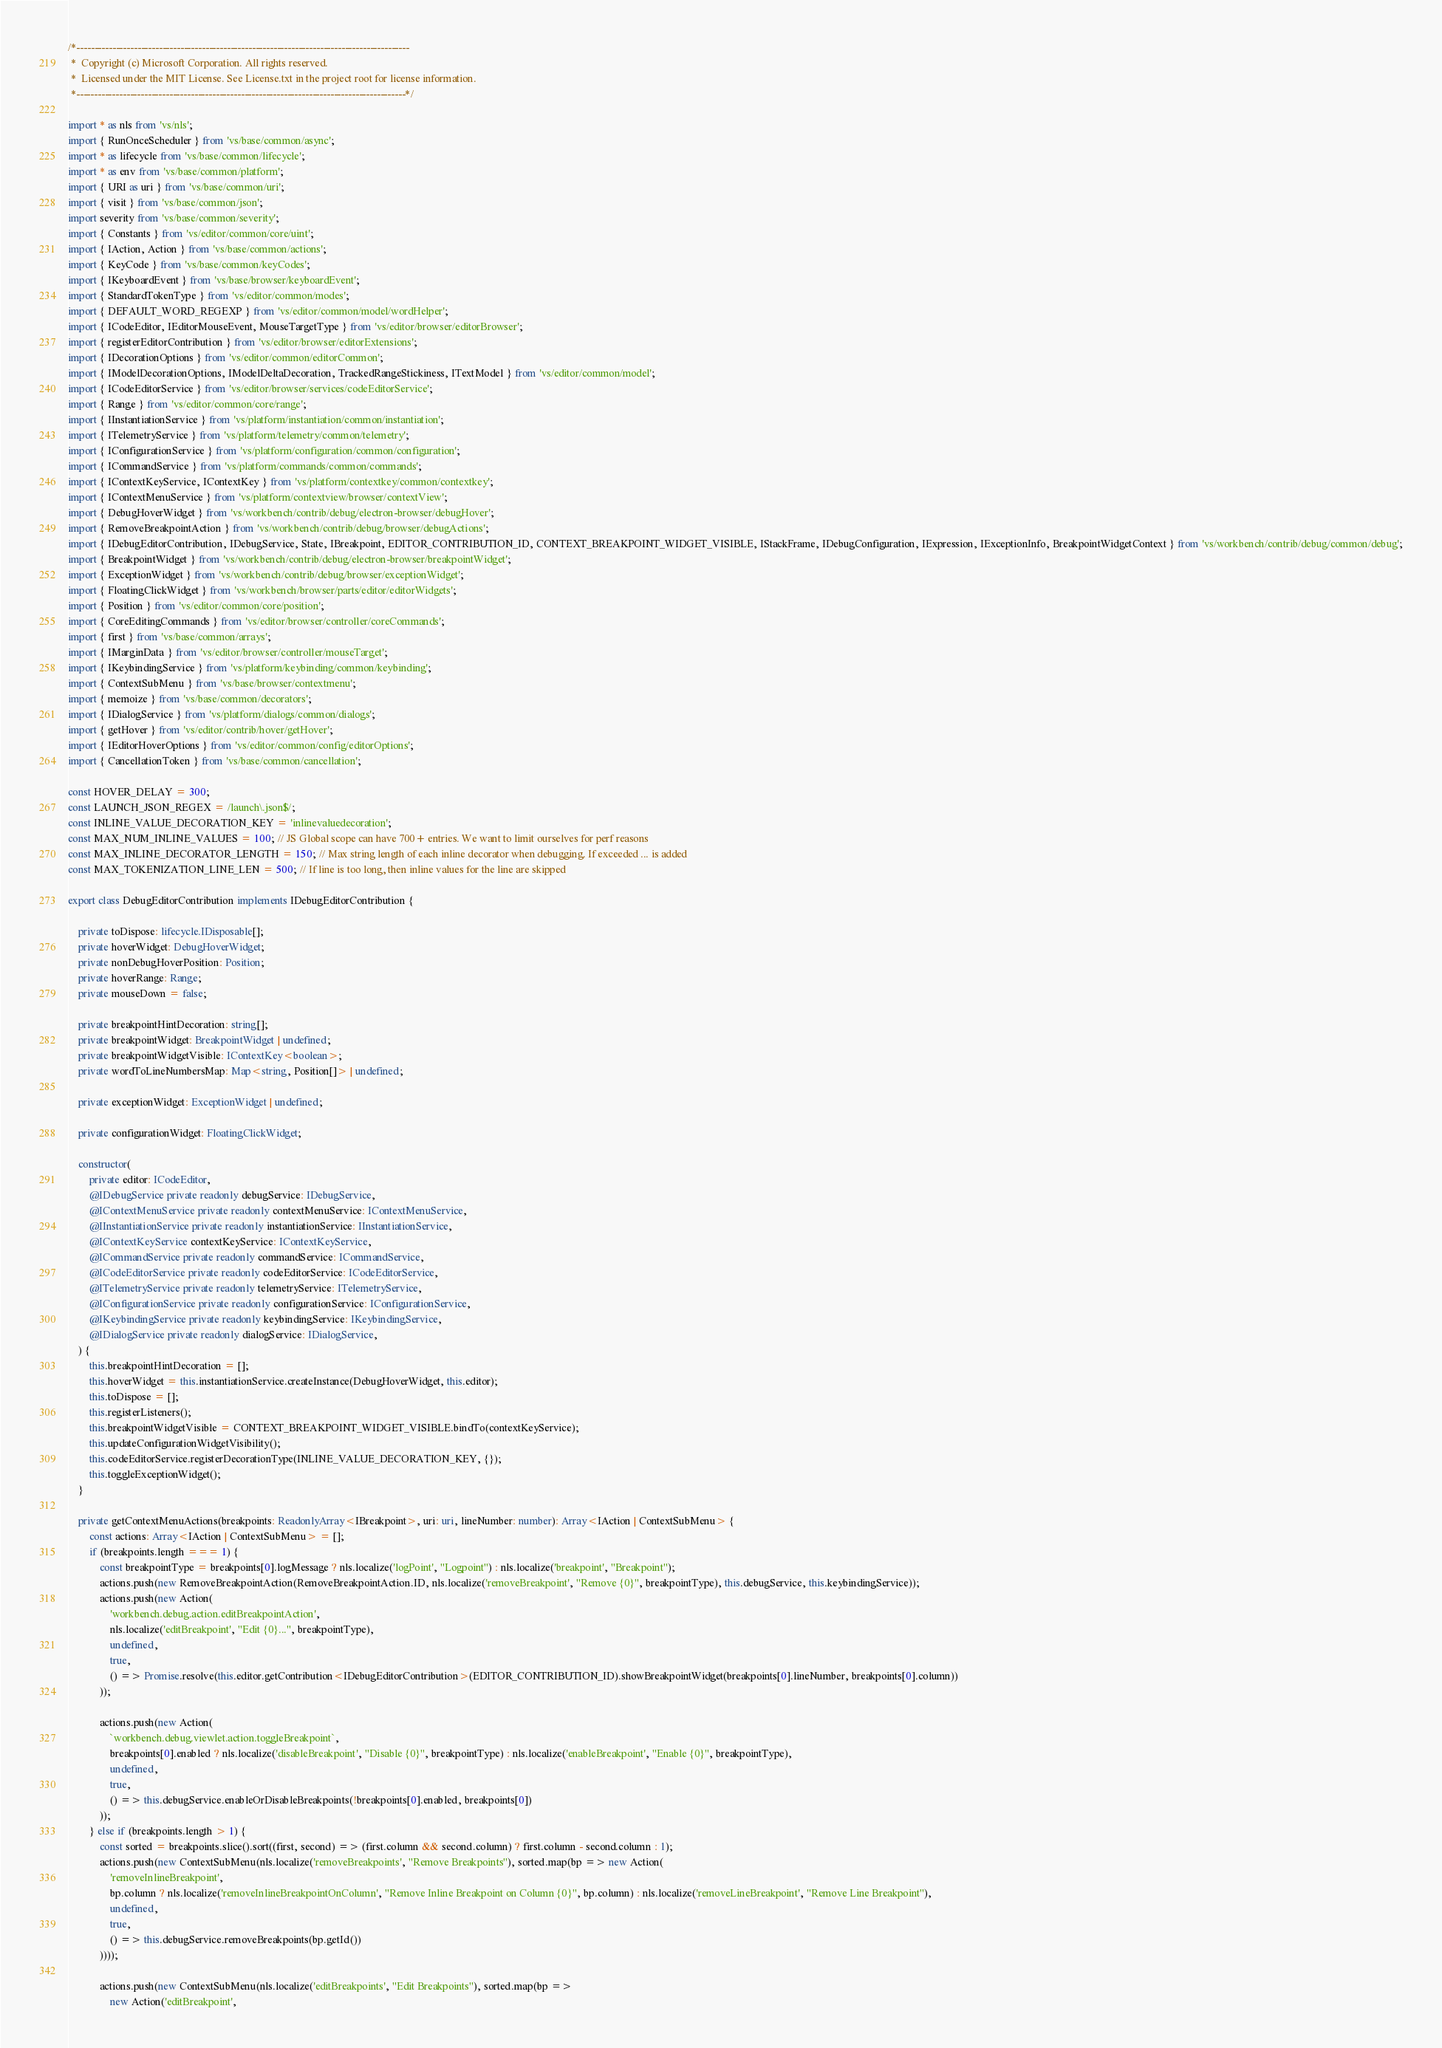Convert code to text. <code><loc_0><loc_0><loc_500><loc_500><_TypeScript_>/*---------------------------------------------------------------------------------------------
 *  Copyright (c) Microsoft Corporation. All rights reserved.
 *  Licensed under the MIT License. See License.txt in the project root for license information.
 *--------------------------------------------------------------------------------------------*/

import * as nls from 'vs/nls';
import { RunOnceScheduler } from 'vs/base/common/async';
import * as lifecycle from 'vs/base/common/lifecycle';
import * as env from 'vs/base/common/platform';
import { URI as uri } from 'vs/base/common/uri';
import { visit } from 'vs/base/common/json';
import severity from 'vs/base/common/severity';
import { Constants } from 'vs/editor/common/core/uint';
import { IAction, Action } from 'vs/base/common/actions';
import { KeyCode } from 'vs/base/common/keyCodes';
import { IKeyboardEvent } from 'vs/base/browser/keyboardEvent';
import { StandardTokenType } from 'vs/editor/common/modes';
import { DEFAULT_WORD_REGEXP } from 'vs/editor/common/model/wordHelper';
import { ICodeEditor, IEditorMouseEvent, MouseTargetType } from 'vs/editor/browser/editorBrowser';
import { registerEditorContribution } from 'vs/editor/browser/editorExtensions';
import { IDecorationOptions } from 'vs/editor/common/editorCommon';
import { IModelDecorationOptions, IModelDeltaDecoration, TrackedRangeStickiness, ITextModel } from 'vs/editor/common/model';
import { ICodeEditorService } from 'vs/editor/browser/services/codeEditorService';
import { Range } from 'vs/editor/common/core/range';
import { IInstantiationService } from 'vs/platform/instantiation/common/instantiation';
import { ITelemetryService } from 'vs/platform/telemetry/common/telemetry';
import { IConfigurationService } from 'vs/platform/configuration/common/configuration';
import { ICommandService } from 'vs/platform/commands/common/commands';
import { IContextKeyService, IContextKey } from 'vs/platform/contextkey/common/contextkey';
import { IContextMenuService } from 'vs/platform/contextview/browser/contextView';
import { DebugHoverWidget } from 'vs/workbench/contrib/debug/electron-browser/debugHover';
import { RemoveBreakpointAction } from 'vs/workbench/contrib/debug/browser/debugActions';
import { IDebugEditorContribution, IDebugService, State, IBreakpoint, EDITOR_CONTRIBUTION_ID, CONTEXT_BREAKPOINT_WIDGET_VISIBLE, IStackFrame, IDebugConfiguration, IExpression, IExceptionInfo, BreakpointWidgetContext } from 'vs/workbench/contrib/debug/common/debug';
import { BreakpointWidget } from 'vs/workbench/contrib/debug/electron-browser/breakpointWidget';
import { ExceptionWidget } from 'vs/workbench/contrib/debug/browser/exceptionWidget';
import { FloatingClickWidget } from 'vs/workbench/browser/parts/editor/editorWidgets';
import { Position } from 'vs/editor/common/core/position';
import { CoreEditingCommands } from 'vs/editor/browser/controller/coreCommands';
import { first } from 'vs/base/common/arrays';
import { IMarginData } from 'vs/editor/browser/controller/mouseTarget';
import { IKeybindingService } from 'vs/platform/keybinding/common/keybinding';
import { ContextSubMenu } from 'vs/base/browser/contextmenu';
import { memoize } from 'vs/base/common/decorators';
import { IDialogService } from 'vs/platform/dialogs/common/dialogs';
import { getHover } from 'vs/editor/contrib/hover/getHover';
import { IEditorHoverOptions } from 'vs/editor/common/config/editorOptions';
import { CancellationToken } from 'vs/base/common/cancellation';

const HOVER_DELAY = 300;
const LAUNCH_JSON_REGEX = /launch\.json$/;
const INLINE_VALUE_DECORATION_KEY = 'inlinevaluedecoration';
const MAX_NUM_INLINE_VALUES = 100; // JS Global scope can have 700+ entries. We want to limit ourselves for perf reasons
const MAX_INLINE_DECORATOR_LENGTH = 150; // Max string length of each inline decorator when debugging. If exceeded ... is added
const MAX_TOKENIZATION_LINE_LEN = 500; // If line is too long, then inline values for the line are skipped

export class DebugEditorContribution implements IDebugEditorContribution {

	private toDispose: lifecycle.IDisposable[];
	private hoverWidget: DebugHoverWidget;
	private nonDebugHoverPosition: Position;
	private hoverRange: Range;
	private mouseDown = false;

	private breakpointHintDecoration: string[];
	private breakpointWidget: BreakpointWidget | undefined;
	private breakpointWidgetVisible: IContextKey<boolean>;
	private wordToLineNumbersMap: Map<string, Position[]> | undefined;

	private exceptionWidget: ExceptionWidget | undefined;

	private configurationWidget: FloatingClickWidget;

	constructor(
		private editor: ICodeEditor,
		@IDebugService private readonly debugService: IDebugService,
		@IContextMenuService private readonly contextMenuService: IContextMenuService,
		@IInstantiationService private readonly instantiationService: IInstantiationService,
		@IContextKeyService contextKeyService: IContextKeyService,
		@ICommandService private readonly commandService: ICommandService,
		@ICodeEditorService private readonly codeEditorService: ICodeEditorService,
		@ITelemetryService private readonly telemetryService: ITelemetryService,
		@IConfigurationService private readonly configurationService: IConfigurationService,
		@IKeybindingService private readonly keybindingService: IKeybindingService,
		@IDialogService private readonly dialogService: IDialogService,
	) {
		this.breakpointHintDecoration = [];
		this.hoverWidget = this.instantiationService.createInstance(DebugHoverWidget, this.editor);
		this.toDispose = [];
		this.registerListeners();
		this.breakpointWidgetVisible = CONTEXT_BREAKPOINT_WIDGET_VISIBLE.bindTo(contextKeyService);
		this.updateConfigurationWidgetVisibility();
		this.codeEditorService.registerDecorationType(INLINE_VALUE_DECORATION_KEY, {});
		this.toggleExceptionWidget();
	}

	private getContextMenuActions(breakpoints: ReadonlyArray<IBreakpoint>, uri: uri, lineNumber: number): Array<IAction | ContextSubMenu> {
		const actions: Array<IAction | ContextSubMenu> = [];
		if (breakpoints.length === 1) {
			const breakpointType = breakpoints[0].logMessage ? nls.localize('logPoint', "Logpoint") : nls.localize('breakpoint', "Breakpoint");
			actions.push(new RemoveBreakpointAction(RemoveBreakpointAction.ID, nls.localize('removeBreakpoint', "Remove {0}", breakpointType), this.debugService, this.keybindingService));
			actions.push(new Action(
				'workbench.debug.action.editBreakpointAction',
				nls.localize('editBreakpoint', "Edit {0}...", breakpointType),
				undefined,
				true,
				() => Promise.resolve(this.editor.getContribution<IDebugEditorContribution>(EDITOR_CONTRIBUTION_ID).showBreakpointWidget(breakpoints[0].lineNumber, breakpoints[0].column))
			));

			actions.push(new Action(
				`workbench.debug.viewlet.action.toggleBreakpoint`,
				breakpoints[0].enabled ? nls.localize('disableBreakpoint', "Disable {0}", breakpointType) : nls.localize('enableBreakpoint', "Enable {0}", breakpointType),
				undefined,
				true,
				() => this.debugService.enableOrDisableBreakpoints(!breakpoints[0].enabled, breakpoints[0])
			));
		} else if (breakpoints.length > 1) {
			const sorted = breakpoints.slice().sort((first, second) => (first.column && second.column) ? first.column - second.column : 1);
			actions.push(new ContextSubMenu(nls.localize('removeBreakpoints', "Remove Breakpoints"), sorted.map(bp => new Action(
				'removeInlineBreakpoint',
				bp.column ? nls.localize('removeInlineBreakpointOnColumn', "Remove Inline Breakpoint on Column {0}", bp.column) : nls.localize('removeLineBreakpoint', "Remove Line Breakpoint"),
				undefined,
				true,
				() => this.debugService.removeBreakpoints(bp.getId())
			))));

			actions.push(new ContextSubMenu(nls.localize('editBreakpoints', "Edit Breakpoints"), sorted.map(bp =>
				new Action('editBreakpoint',</code> 